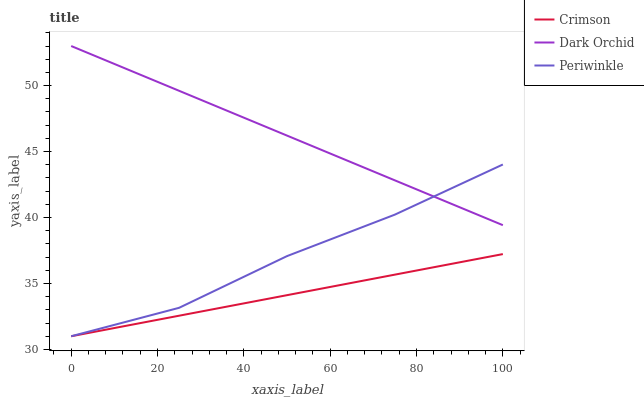Does Periwinkle have the minimum area under the curve?
Answer yes or no. No. Does Periwinkle have the maximum area under the curve?
Answer yes or no. No. Is Periwinkle the smoothest?
Answer yes or no. No. Is Dark Orchid the roughest?
Answer yes or no. No. Does Dark Orchid have the lowest value?
Answer yes or no. No. Does Periwinkle have the highest value?
Answer yes or no. No. Is Crimson less than Dark Orchid?
Answer yes or no. Yes. Is Dark Orchid greater than Crimson?
Answer yes or no. Yes. Does Crimson intersect Dark Orchid?
Answer yes or no. No. 